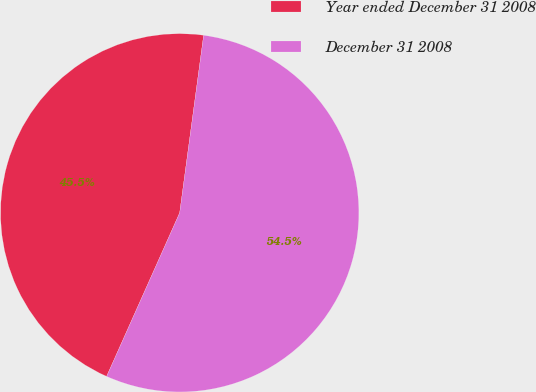Convert chart. <chart><loc_0><loc_0><loc_500><loc_500><pie_chart><fcel>Year ended December 31 2008<fcel>December 31 2008<nl><fcel>45.45%<fcel>54.55%<nl></chart> 